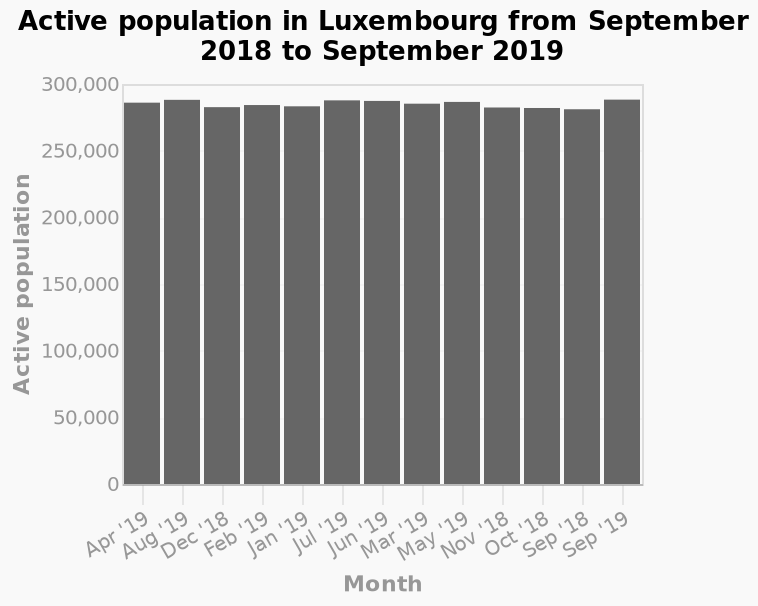<image>
Was there any significant population growth or decline in Luxembourg during the given period? No, there was no significant population growth or decline in Luxembourg during the period from September 2018 to September 2019. The population remained stable at around 290,000. What can be concluded about the population of Luxembourg based on the given information? Based on the given information, it can be concluded that the population of Luxembourg remained relatively constant from September 2018 to September 2019, with no significant changes. What is plotted along the x-axis of the bar plot? Along the x-axis of the bar plot, the months are plotted using a categorical scale starting from Apr '19 and ending with Sep '19. 